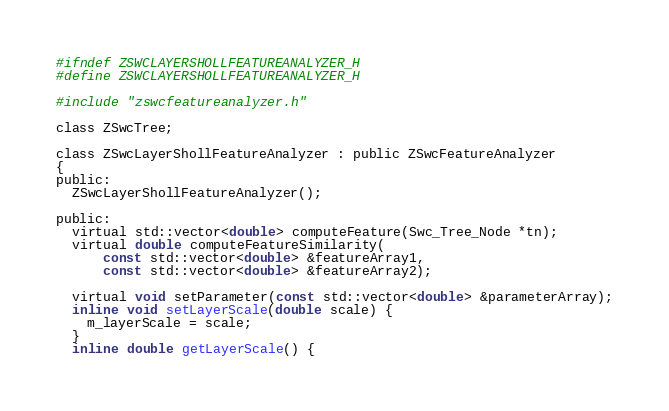<code> <loc_0><loc_0><loc_500><loc_500><_C_>#ifndef ZSWCLAYERSHOLLFEATUREANALYZER_H
#define ZSWCLAYERSHOLLFEATUREANALYZER_H

#include "zswcfeatureanalyzer.h"

class ZSwcTree;

class ZSwcLayerShollFeatureAnalyzer : public ZSwcFeatureAnalyzer
{
public:
  ZSwcLayerShollFeatureAnalyzer();

public:
  virtual std::vector<double> computeFeature(Swc_Tree_Node *tn);
  virtual double computeFeatureSimilarity(
      const std::vector<double> &featureArray1,
      const std::vector<double> &featureArray2);

  virtual void setParameter(const std::vector<double> &parameterArray);
  inline void setLayerScale(double scale) {
    m_layerScale = scale;
  }
  inline double getLayerScale() {</code> 